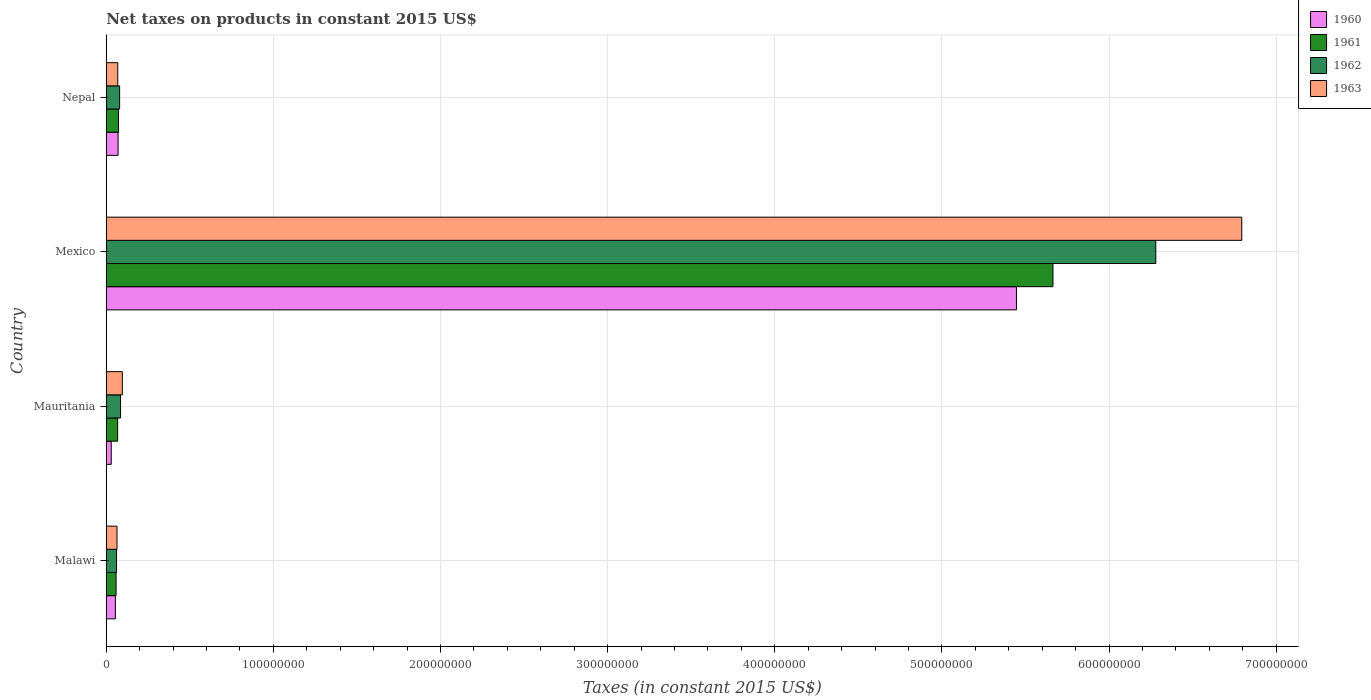How many different coloured bars are there?
Provide a succinct answer. 4. Are the number of bars per tick equal to the number of legend labels?
Make the answer very short. Yes. Are the number of bars on each tick of the Y-axis equal?
Provide a succinct answer. Yes. How many bars are there on the 4th tick from the top?
Your answer should be very brief. 4. What is the label of the 2nd group of bars from the top?
Keep it short and to the point. Mexico. In how many cases, is the number of bars for a given country not equal to the number of legend labels?
Your answer should be compact. 0. What is the net taxes on products in 1963 in Nepal?
Provide a short and direct response. 6.89e+06. Across all countries, what is the maximum net taxes on products in 1960?
Ensure brevity in your answer.  5.45e+08. Across all countries, what is the minimum net taxes on products in 1960?
Keep it short and to the point. 3.00e+06. In which country was the net taxes on products in 1962 minimum?
Give a very brief answer. Malawi. What is the total net taxes on products in 1962 in the graph?
Keep it short and to the point. 6.51e+08. What is the difference between the net taxes on products in 1961 in Mauritania and that in Nepal?
Your answer should be compact. -5.03e+05. What is the difference between the net taxes on products in 1961 in Malawi and the net taxes on products in 1962 in Mexico?
Make the answer very short. -6.22e+08. What is the average net taxes on products in 1963 per country?
Your response must be concise. 1.76e+08. What is the difference between the net taxes on products in 1963 and net taxes on products in 1962 in Mauritania?
Offer a very short reply. 1.07e+06. In how many countries, is the net taxes on products in 1963 greater than 360000000 US$?
Ensure brevity in your answer.  1. What is the ratio of the net taxes on products in 1962 in Mauritania to that in Nepal?
Provide a succinct answer. 1.07. Is the difference between the net taxes on products in 1963 in Mauritania and Mexico greater than the difference between the net taxes on products in 1962 in Mauritania and Mexico?
Ensure brevity in your answer.  No. What is the difference between the highest and the second highest net taxes on products in 1960?
Your answer should be very brief. 5.37e+08. What is the difference between the highest and the lowest net taxes on products in 1961?
Your response must be concise. 5.61e+08. Is it the case that in every country, the sum of the net taxes on products in 1963 and net taxes on products in 1962 is greater than the net taxes on products in 1961?
Offer a very short reply. Yes. How many countries are there in the graph?
Provide a short and direct response. 4. What is the difference between two consecutive major ticks on the X-axis?
Make the answer very short. 1.00e+08. Are the values on the major ticks of X-axis written in scientific E-notation?
Give a very brief answer. No. Does the graph contain any zero values?
Ensure brevity in your answer.  No. How many legend labels are there?
Keep it short and to the point. 4. What is the title of the graph?
Your answer should be very brief. Net taxes on products in constant 2015 US$. Does "2012" appear as one of the legend labels in the graph?
Offer a very short reply. No. What is the label or title of the X-axis?
Your answer should be very brief. Taxes (in constant 2015 US$). What is the Taxes (in constant 2015 US$) in 1960 in Malawi?
Offer a very short reply. 5.46e+06. What is the Taxes (in constant 2015 US$) in 1961 in Malawi?
Offer a very short reply. 5.88e+06. What is the Taxes (in constant 2015 US$) of 1962 in Malawi?
Keep it short and to the point. 6.16e+06. What is the Taxes (in constant 2015 US$) in 1963 in Malawi?
Your response must be concise. 6.44e+06. What is the Taxes (in constant 2015 US$) of 1960 in Mauritania?
Provide a succinct answer. 3.00e+06. What is the Taxes (in constant 2015 US$) in 1961 in Mauritania?
Your response must be concise. 6.85e+06. What is the Taxes (in constant 2015 US$) of 1962 in Mauritania?
Give a very brief answer. 8.56e+06. What is the Taxes (in constant 2015 US$) in 1963 in Mauritania?
Make the answer very short. 9.63e+06. What is the Taxes (in constant 2015 US$) in 1960 in Mexico?
Provide a succinct answer. 5.45e+08. What is the Taxes (in constant 2015 US$) in 1961 in Mexico?
Make the answer very short. 5.66e+08. What is the Taxes (in constant 2015 US$) in 1962 in Mexico?
Provide a succinct answer. 6.28e+08. What is the Taxes (in constant 2015 US$) in 1963 in Mexico?
Provide a succinct answer. 6.79e+08. What is the Taxes (in constant 2015 US$) of 1960 in Nepal?
Your answer should be very brief. 7.09e+06. What is the Taxes (in constant 2015 US$) in 1961 in Nepal?
Provide a short and direct response. 7.35e+06. What is the Taxes (in constant 2015 US$) of 1962 in Nepal?
Give a very brief answer. 8.01e+06. What is the Taxes (in constant 2015 US$) in 1963 in Nepal?
Ensure brevity in your answer.  6.89e+06. Across all countries, what is the maximum Taxes (in constant 2015 US$) in 1960?
Your answer should be very brief. 5.45e+08. Across all countries, what is the maximum Taxes (in constant 2015 US$) of 1961?
Give a very brief answer. 5.66e+08. Across all countries, what is the maximum Taxes (in constant 2015 US$) of 1962?
Offer a very short reply. 6.28e+08. Across all countries, what is the maximum Taxes (in constant 2015 US$) of 1963?
Provide a succinct answer. 6.79e+08. Across all countries, what is the minimum Taxes (in constant 2015 US$) in 1960?
Provide a short and direct response. 3.00e+06. Across all countries, what is the minimum Taxes (in constant 2015 US$) in 1961?
Your answer should be very brief. 5.88e+06. Across all countries, what is the minimum Taxes (in constant 2015 US$) in 1962?
Provide a short and direct response. 6.16e+06. Across all countries, what is the minimum Taxes (in constant 2015 US$) in 1963?
Keep it short and to the point. 6.44e+06. What is the total Taxes (in constant 2015 US$) in 1960 in the graph?
Keep it short and to the point. 5.60e+08. What is the total Taxes (in constant 2015 US$) of 1961 in the graph?
Keep it short and to the point. 5.86e+08. What is the total Taxes (in constant 2015 US$) of 1962 in the graph?
Provide a short and direct response. 6.51e+08. What is the total Taxes (in constant 2015 US$) of 1963 in the graph?
Your response must be concise. 7.02e+08. What is the difference between the Taxes (in constant 2015 US$) in 1960 in Malawi and that in Mauritania?
Your answer should be very brief. 2.46e+06. What is the difference between the Taxes (in constant 2015 US$) in 1961 in Malawi and that in Mauritania?
Your answer should be compact. -9.67e+05. What is the difference between the Taxes (in constant 2015 US$) in 1962 in Malawi and that in Mauritania?
Provide a short and direct response. -2.40e+06. What is the difference between the Taxes (in constant 2015 US$) of 1963 in Malawi and that in Mauritania?
Make the answer very short. -3.19e+06. What is the difference between the Taxes (in constant 2015 US$) of 1960 in Malawi and that in Mexico?
Ensure brevity in your answer.  -5.39e+08. What is the difference between the Taxes (in constant 2015 US$) of 1961 in Malawi and that in Mexico?
Your answer should be compact. -5.61e+08. What is the difference between the Taxes (in constant 2015 US$) in 1962 in Malawi and that in Mexico?
Provide a succinct answer. -6.22e+08. What is the difference between the Taxes (in constant 2015 US$) of 1963 in Malawi and that in Mexico?
Ensure brevity in your answer.  -6.73e+08. What is the difference between the Taxes (in constant 2015 US$) of 1960 in Malawi and that in Nepal?
Keep it short and to the point. -1.63e+06. What is the difference between the Taxes (in constant 2015 US$) of 1961 in Malawi and that in Nepal?
Provide a succinct answer. -1.47e+06. What is the difference between the Taxes (in constant 2015 US$) in 1962 in Malawi and that in Nepal?
Make the answer very short. -1.85e+06. What is the difference between the Taxes (in constant 2015 US$) of 1963 in Malawi and that in Nepal?
Your answer should be very brief. -4.50e+05. What is the difference between the Taxes (in constant 2015 US$) of 1960 in Mauritania and that in Mexico?
Keep it short and to the point. -5.42e+08. What is the difference between the Taxes (in constant 2015 US$) of 1961 in Mauritania and that in Mexico?
Your answer should be compact. -5.60e+08. What is the difference between the Taxes (in constant 2015 US$) of 1962 in Mauritania and that in Mexico?
Your answer should be very brief. -6.19e+08. What is the difference between the Taxes (in constant 2015 US$) in 1963 in Mauritania and that in Mexico?
Offer a very short reply. -6.70e+08. What is the difference between the Taxes (in constant 2015 US$) in 1960 in Mauritania and that in Nepal?
Keep it short and to the point. -4.09e+06. What is the difference between the Taxes (in constant 2015 US$) of 1961 in Mauritania and that in Nepal?
Keep it short and to the point. -5.03e+05. What is the difference between the Taxes (in constant 2015 US$) in 1962 in Mauritania and that in Nepal?
Offer a terse response. 5.53e+05. What is the difference between the Taxes (in constant 2015 US$) in 1963 in Mauritania and that in Nepal?
Provide a succinct answer. 2.74e+06. What is the difference between the Taxes (in constant 2015 US$) in 1960 in Mexico and that in Nepal?
Provide a succinct answer. 5.37e+08. What is the difference between the Taxes (in constant 2015 US$) of 1961 in Mexico and that in Nepal?
Ensure brevity in your answer.  5.59e+08. What is the difference between the Taxes (in constant 2015 US$) of 1962 in Mexico and that in Nepal?
Offer a terse response. 6.20e+08. What is the difference between the Taxes (in constant 2015 US$) in 1963 in Mexico and that in Nepal?
Ensure brevity in your answer.  6.72e+08. What is the difference between the Taxes (in constant 2015 US$) of 1960 in Malawi and the Taxes (in constant 2015 US$) of 1961 in Mauritania?
Your answer should be very brief. -1.39e+06. What is the difference between the Taxes (in constant 2015 US$) of 1960 in Malawi and the Taxes (in constant 2015 US$) of 1962 in Mauritania?
Give a very brief answer. -3.10e+06. What is the difference between the Taxes (in constant 2015 US$) of 1960 in Malawi and the Taxes (in constant 2015 US$) of 1963 in Mauritania?
Provide a short and direct response. -4.17e+06. What is the difference between the Taxes (in constant 2015 US$) of 1961 in Malawi and the Taxes (in constant 2015 US$) of 1962 in Mauritania?
Keep it short and to the point. -2.68e+06. What is the difference between the Taxes (in constant 2015 US$) in 1961 in Malawi and the Taxes (in constant 2015 US$) in 1963 in Mauritania?
Offer a terse response. -3.75e+06. What is the difference between the Taxes (in constant 2015 US$) in 1962 in Malawi and the Taxes (in constant 2015 US$) in 1963 in Mauritania?
Your response must be concise. -3.47e+06. What is the difference between the Taxes (in constant 2015 US$) of 1960 in Malawi and the Taxes (in constant 2015 US$) of 1961 in Mexico?
Your answer should be compact. -5.61e+08. What is the difference between the Taxes (in constant 2015 US$) of 1960 in Malawi and the Taxes (in constant 2015 US$) of 1962 in Mexico?
Ensure brevity in your answer.  -6.22e+08. What is the difference between the Taxes (in constant 2015 US$) in 1960 in Malawi and the Taxes (in constant 2015 US$) in 1963 in Mexico?
Make the answer very short. -6.74e+08. What is the difference between the Taxes (in constant 2015 US$) of 1961 in Malawi and the Taxes (in constant 2015 US$) of 1962 in Mexico?
Keep it short and to the point. -6.22e+08. What is the difference between the Taxes (in constant 2015 US$) of 1961 in Malawi and the Taxes (in constant 2015 US$) of 1963 in Mexico?
Give a very brief answer. -6.73e+08. What is the difference between the Taxes (in constant 2015 US$) of 1962 in Malawi and the Taxes (in constant 2015 US$) of 1963 in Mexico?
Offer a terse response. -6.73e+08. What is the difference between the Taxes (in constant 2015 US$) in 1960 in Malawi and the Taxes (in constant 2015 US$) in 1961 in Nepal?
Offer a terse response. -1.89e+06. What is the difference between the Taxes (in constant 2015 US$) in 1960 in Malawi and the Taxes (in constant 2015 US$) in 1962 in Nepal?
Ensure brevity in your answer.  -2.55e+06. What is the difference between the Taxes (in constant 2015 US$) in 1960 in Malawi and the Taxes (in constant 2015 US$) in 1963 in Nepal?
Give a very brief answer. -1.43e+06. What is the difference between the Taxes (in constant 2015 US$) of 1961 in Malawi and the Taxes (in constant 2015 US$) of 1962 in Nepal?
Provide a succinct answer. -2.13e+06. What is the difference between the Taxes (in constant 2015 US$) in 1961 in Malawi and the Taxes (in constant 2015 US$) in 1963 in Nepal?
Your answer should be very brief. -1.01e+06. What is the difference between the Taxes (in constant 2015 US$) of 1962 in Malawi and the Taxes (in constant 2015 US$) of 1963 in Nepal?
Your answer should be compact. -7.30e+05. What is the difference between the Taxes (in constant 2015 US$) of 1960 in Mauritania and the Taxes (in constant 2015 US$) of 1961 in Mexico?
Provide a succinct answer. -5.63e+08. What is the difference between the Taxes (in constant 2015 US$) in 1960 in Mauritania and the Taxes (in constant 2015 US$) in 1962 in Mexico?
Give a very brief answer. -6.25e+08. What is the difference between the Taxes (in constant 2015 US$) of 1960 in Mauritania and the Taxes (in constant 2015 US$) of 1963 in Mexico?
Ensure brevity in your answer.  -6.76e+08. What is the difference between the Taxes (in constant 2015 US$) in 1961 in Mauritania and the Taxes (in constant 2015 US$) in 1962 in Mexico?
Ensure brevity in your answer.  -6.21e+08. What is the difference between the Taxes (in constant 2015 US$) of 1961 in Mauritania and the Taxes (in constant 2015 US$) of 1963 in Mexico?
Your answer should be very brief. -6.73e+08. What is the difference between the Taxes (in constant 2015 US$) in 1962 in Mauritania and the Taxes (in constant 2015 US$) in 1963 in Mexico?
Give a very brief answer. -6.71e+08. What is the difference between the Taxes (in constant 2015 US$) in 1960 in Mauritania and the Taxes (in constant 2015 US$) in 1961 in Nepal?
Your answer should be compact. -4.35e+06. What is the difference between the Taxes (in constant 2015 US$) of 1960 in Mauritania and the Taxes (in constant 2015 US$) of 1962 in Nepal?
Give a very brief answer. -5.01e+06. What is the difference between the Taxes (in constant 2015 US$) of 1960 in Mauritania and the Taxes (in constant 2015 US$) of 1963 in Nepal?
Offer a terse response. -3.89e+06. What is the difference between the Taxes (in constant 2015 US$) in 1961 in Mauritania and the Taxes (in constant 2015 US$) in 1962 in Nepal?
Give a very brief answer. -1.16e+06. What is the difference between the Taxes (in constant 2015 US$) of 1961 in Mauritania and the Taxes (in constant 2015 US$) of 1963 in Nepal?
Provide a succinct answer. -4.29e+04. What is the difference between the Taxes (in constant 2015 US$) of 1962 in Mauritania and the Taxes (in constant 2015 US$) of 1963 in Nepal?
Your response must be concise. 1.67e+06. What is the difference between the Taxes (in constant 2015 US$) of 1960 in Mexico and the Taxes (in constant 2015 US$) of 1961 in Nepal?
Make the answer very short. 5.37e+08. What is the difference between the Taxes (in constant 2015 US$) of 1960 in Mexico and the Taxes (in constant 2015 US$) of 1962 in Nepal?
Offer a terse response. 5.37e+08. What is the difference between the Taxes (in constant 2015 US$) in 1960 in Mexico and the Taxes (in constant 2015 US$) in 1963 in Nepal?
Offer a very short reply. 5.38e+08. What is the difference between the Taxes (in constant 2015 US$) of 1961 in Mexico and the Taxes (in constant 2015 US$) of 1962 in Nepal?
Your response must be concise. 5.58e+08. What is the difference between the Taxes (in constant 2015 US$) of 1961 in Mexico and the Taxes (in constant 2015 US$) of 1963 in Nepal?
Give a very brief answer. 5.60e+08. What is the difference between the Taxes (in constant 2015 US$) in 1962 in Mexico and the Taxes (in constant 2015 US$) in 1963 in Nepal?
Your response must be concise. 6.21e+08. What is the average Taxes (in constant 2015 US$) of 1960 per country?
Offer a terse response. 1.40e+08. What is the average Taxes (in constant 2015 US$) of 1961 per country?
Keep it short and to the point. 1.47e+08. What is the average Taxes (in constant 2015 US$) in 1962 per country?
Ensure brevity in your answer.  1.63e+08. What is the average Taxes (in constant 2015 US$) in 1963 per country?
Provide a short and direct response. 1.76e+08. What is the difference between the Taxes (in constant 2015 US$) in 1960 and Taxes (in constant 2015 US$) in 1961 in Malawi?
Ensure brevity in your answer.  -4.20e+05. What is the difference between the Taxes (in constant 2015 US$) of 1960 and Taxes (in constant 2015 US$) of 1962 in Malawi?
Offer a very short reply. -7.00e+05. What is the difference between the Taxes (in constant 2015 US$) of 1960 and Taxes (in constant 2015 US$) of 1963 in Malawi?
Keep it short and to the point. -9.80e+05. What is the difference between the Taxes (in constant 2015 US$) in 1961 and Taxes (in constant 2015 US$) in 1962 in Malawi?
Your response must be concise. -2.80e+05. What is the difference between the Taxes (in constant 2015 US$) in 1961 and Taxes (in constant 2015 US$) in 1963 in Malawi?
Offer a terse response. -5.60e+05. What is the difference between the Taxes (in constant 2015 US$) in 1962 and Taxes (in constant 2015 US$) in 1963 in Malawi?
Your answer should be very brief. -2.80e+05. What is the difference between the Taxes (in constant 2015 US$) of 1960 and Taxes (in constant 2015 US$) of 1961 in Mauritania?
Ensure brevity in your answer.  -3.85e+06. What is the difference between the Taxes (in constant 2015 US$) in 1960 and Taxes (in constant 2015 US$) in 1962 in Mauritania?
Your answer should be very brief. -5.56e+06. What is the difference between the Taxes (in constant 2015 US$) in 1960 and Taxes (in constant 2015 US$) in 1963 in Mauritania?
Keep it short and to the point. -6.63e+06. What is the difference between the Taxes (in constant 2015 US$) in 1961 and Taxes (in constant 2015 US$) in 1962 in Mauritania?
Keep it short and to the point. -1.71e+06. What is the difference between the Taxes (in constant 2015 US$) of 1961 and Taxes (in constant 2015 US$) of 1963 in Mauritania?
Ensure brevity in your answer.  -2.78e+06. What is the difference between the Taxes (in constant 2015 US$) in 1962 and Taxes (in constant 2015 US$) in 1963 in Mauritania?
Offer a terse response. -1.07e+06. What is the difference between the Taxes (in constant 2015 US$) of 1960 and Taxes (in constant 2015 US$) of 1961 in Mexico?
Your answer should be very brief. -2.18e+07. What is the difference between the Taxes (in constant 2015 US$) of 1960 and Taxes (in constant 2015 US$) of 1962 in Mexico?
Make the answer very short. -8.34e+07. What is the difference between the Taxes (in constant 2015 US$) of 1960 and Taxes (in constant 2015 US$) of 1963 in Mexico?
Make the answer very short. -1.35e+08. What is the difference between the Taxes (in constant 2015 US$) of 1961 and Taxes (in constant 2015 US$) of 1962 in Mexico?
Provide a succinct answer. -6.15e+07. What is the difference between the Taxes (in constant 2015 US$) in 1961 and Taxes (in constant 2015 US$) in 1963 in Mexico?
Your answer should be compact. -1.13e+08. What is the difference between the Taxes (in constant 2015 US$) of 1962 and Taxes (in constant 2015 US$) of 1963 in Mexico?
Offer a very short reply. -5.14e+07. What is the difference between the Taxes (in constant 2015 US$) in 1960 and Taxes (in constant 2015 US$) in 1961 in Nepal?
Provide a succinct answer. -2.63e+05. What is the difference between the Taxes (in constant 2015 US$) of 1960 and Taxes (in constant 2015 US$) of 1962 in Nepal?
Offer a terse response. -9.19e+05. What is the difference between the Taxes (in constant 2015 US$) of 1960 and Taxes (in constant 2015 US$) of 1963 in Nepal?
Ensure brevity in your answer.  1.97e+05. What is the difference between the Taxes (in constant 2015 US$) of 1961 and Taxes (in constant 2015 US$) of 1962 in Nepal?
Give a very brief answer. -6.56e+05. What is the difference between the Taxes (in constant 2015 US$) of 1961 and Taxes (in constant 2015 US$) of 1963 in Nepal?
Your answer should be compact. 4.60e+05. What is the difference between the Taxes (in constant 2015 US$) in 1962 and Taxes (in constant 2015 US$) in 1963 in Nepal?
Ensure brevity in your answer.  1.12e+06. What is the ratio of the Taxes (in constant 2015 US$) of 1960 in Malawi to that in Mauritania?
Offer a terse response. 1.82. What is the ratio of the Taxes (in constant 2015 US$) in 1961 in Malawi to that in Mauritania?
Keep it short and to the point. 0.86. What is the ratio of the Taxes (in constant 2015 US$) in 1962 in Malawi to that in Mauritania?
Keep it short and to the point. 0.72. What is the ratio of the Taxes (in constant 2015 US$) in 1963 in Malawi to that in Mauritania?
Ensure brevity in your answer.  0.67. What is the ratio of the Taxes (in constant 2015 US$) of 1961 in Malawi to that in Mexico?
Your answer should be compact. 0.01. What is the ratio of the Taxes (in constant 2015 US$) in 1962 in Malawi to that in Mexico?
Your answer should be very brief. 0.01. What is the ratio of the Taxes (in constant 2015 US$) in 1963 in Malawi to that in Mexico?
Make the answer very short. 0.01. What is the ratio of the Taxes (in constant 2015 US$) in 1960 in Malawi to that in Nepal?
Offer a very short reply. 0.77. What is the ratio of the Taxes (in constant 2015 US$) in 1962 in Malawi to that in Nepal?
Provide a succinct answer. 0.77. What is the ratio of the Taxes (in constant 2015 US$) of 1963 in Malawi to that in Nepal?
Your response must be concise. 0.93. What is the ratio of the Taxes (in constant 2015 US$) in 1960 in Mauritania to that in Mexico?
Make the answer very short. 0.01. What is the ratio of the Taxes (in constant 2015 US$) in 1961 in Mauritania to that in Mexico?
Give a very brief answer. 0.01. What is the ratio of the Taxes (in constant 2015 US$) in 1962 in Mauritania to that in Mexico?
Give a very brief answer. 0.01. What is the ratio of the Taxes (in constant 2015 US$) in 1963 in Mauritania to that in Mexico?
Give a very brief answer. 0.01. What is the ratio of the Taxes (in constant 2015 US$) in 1960 in Mauritania to that in Nepal?
Offer a terse response. 0.42. What is the ratio of the Taxes (in constant 2015 US$) of 1961 in Mauritania to that in Nepal?
Offer a terse response. 0.93. What is the ratio of the Taxes (in constant 2015 US$) in 1962 in Mauritania to that in Nepal?
Ensure brevity in your answer.  1.07. What is the ratio of the Taxes (in constant 2015 US$) of 1963 in Mauritania to that in Nepal?
Ensure brevity in your answer.  1.4. What is the ratio of the Taxes (in constant 2015 US$) of 1960 in Mexico to that in Nepal?
Offer a very short reply. 76.83. What is the ratio of the Taxes (in constant 2015 US$) of 1961 in Mexico to that in Nepal?
Ensure brevity in your answer.  77.06. What is the ratio of the Taxes (in constant 2015 US$) in 1962 in Mexico to that in Nepal?
Give a very brief answer. 78.43. What is the ratio of the Taxes (in constant 2015 US$) of 1963 in Mexico to that in Nepal?
Keep it short and to the point. 98.6. What is the difference between the highest and the second highest Taxes (in constant 2015 US$) in 1960?
Keep it short and to the point. 5.37e+08. What is the difference between the highest and the second highest Taxes (in constant 2015 US$) of 1961?
Offer a terse response. 5.59e+08. What is the difference between the highest and the second highest Taxes (in constant 2015 US$) in 1962?
Keep it short and to the point. 6.19e+08. What is the difference between the highest and the second highest Taxes (in constant 2015 US$) in 1963?
Your answer should be very brief. 6.70e+08. What is the difference between the highest and the lowest Taxes (in constant 2015 US$) of 1960?
Make the answer very short. 5.42e+08. What is the difference between the highest and the lowest Taxes (in constant 2015 US$) of 1961?
Offer a very short reply. 5.61e+08. What is the difference between the highest and the lowest Taxes (in constant 2015 US$) of 1962?
Provide a succinct answer. 6.22e+08. What is the difference between the highest and the lowest Taxes (in constant 2015 US$) in 1963?
Give a very brief answer. 6.73e+08. 